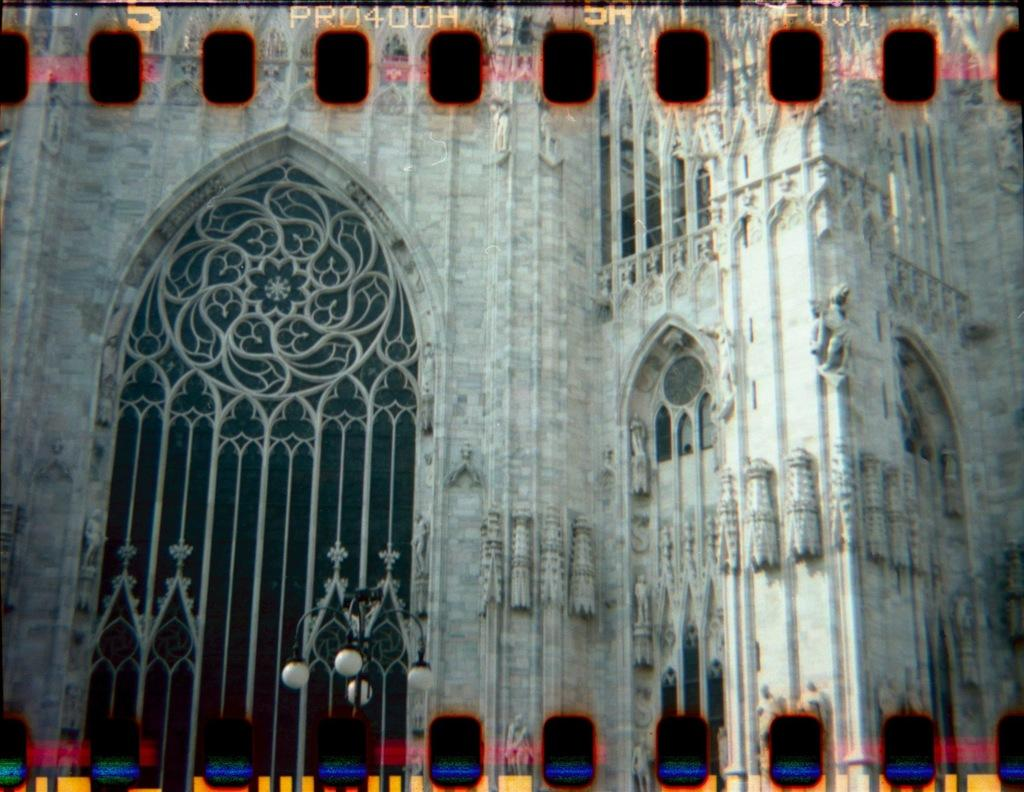What type of structure is visible in the image? There is a building in the image. Where is the door located on the building? The door is on the left side of the building. What type of lighting fixture can be seen in the image? There is a street light in the image. Can you describe any additional features on the image? There is a watermark on the top of the image. How many horses are visible in the image? There are no horses present in the image. What is the amount of water in the image? There is no visible water in the image. 